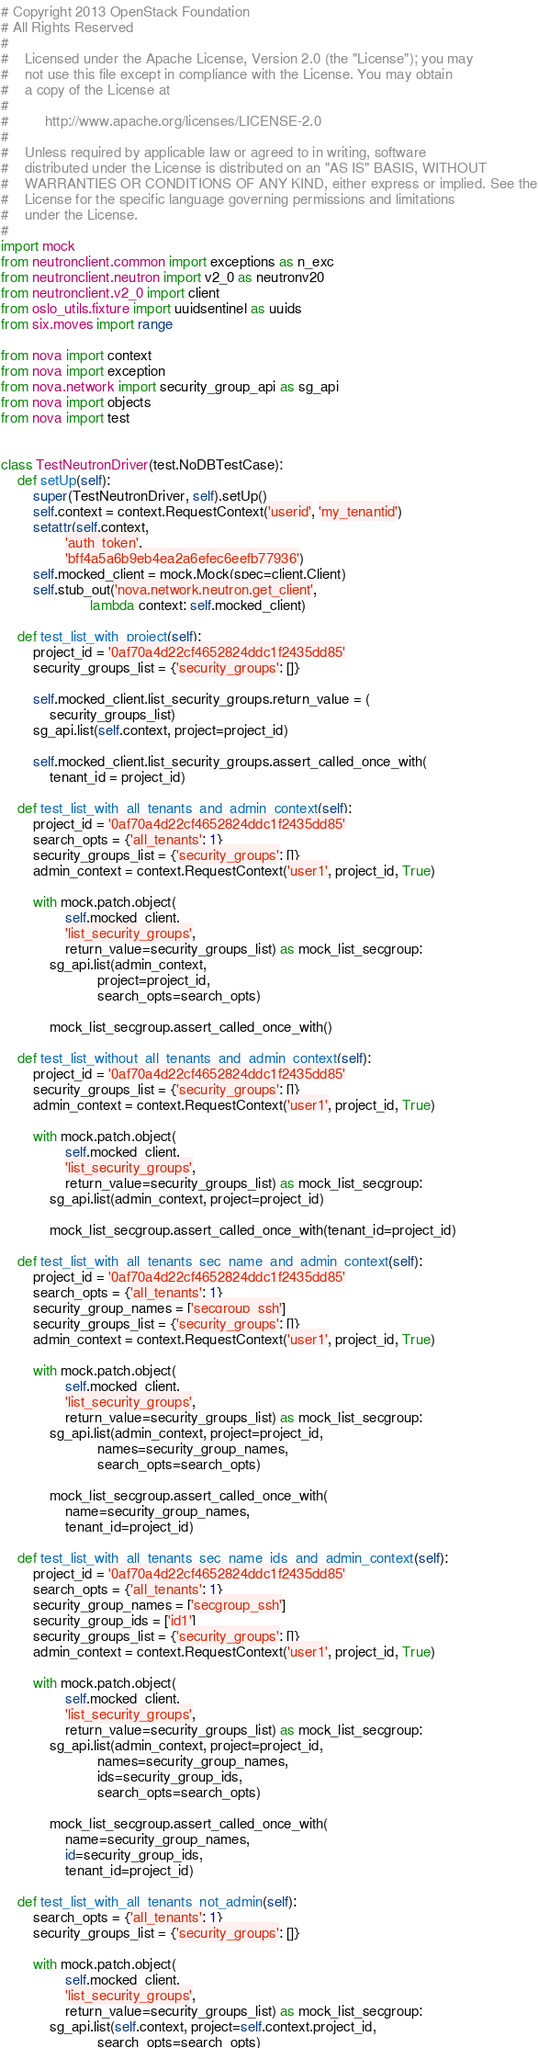Convert code to text. <code><loc_0><loc_0><loc_500><loc_500><_Python_># Copyright 2013 OpenStack Foundation
# All Rights Reserved
#
#    Licensed under the Apache License, Version 2.0 (the "License"); you may
#    not use this file except in compliance with the License. You may obtain
#    a copy of the License at
#
#         http://www.apache.org/licenses/LICENSE-2.0
#
#    Unless required by applicable law or agreed to in writing, software
#    distributed under the License is distributed on an "AS IS" BASIS, WITHOUT
#    WARRANTIES OR CONDITIONS OF ANY KIND, either express or implied. See the
#    License for the specific language governing permissions and limitations
#    under the License.
#
import mock
from neutronclient.common import exceptions as n_exc
from neutronclient.neutron import v2_0 as neutronv20
from neutronclient.v2_0 import client
from oslo_utils.fixture import uuidsentinel as uuids
from six.moves import range

from nova import context
from nova import exception
from nova.network import security_group_api as sg_api
from nova import objects
from nova import test


class TestNeutronDriver(test.NoDBTestCase):
    def setUp(self):
        super(TestNeutronDriver, self).setUp()
        self.context = context.RequestContext('userid', 'my_tenantid')
        setattr(self.context,
                'auth_token',
                'bff4a5a6b9eb4ea2a6efec6eefb77936')
        self.mocked_client = mock.Mock(spec=client.Client)
        self.stub_out('nova.network.neutron.get_client',
                      lambda context: self.mocked_client)

    def test_list_with_project(self):
        project_id = '0af70a4d22cf4652824ddc1f2435dd85'
        security_groups_list = {'security_groups': []}

        self.mocked_client.list_security_groups.return_value = (
            security_groups_list)
        sg_api.list(self.context, project=project_id)

        self.mocked_client.list_security_groups.assert_called_once_with(
            tenant_id = project_id)

    def test_list_with_all_tenants_and_admin_context(self):
        project_id = '0af70a4d22cf4652824ddc1f2435dd85'
        search_opts = {'all_tenants': 1}
        security_groups_list = {'security_groups': []}
        admin_context = context.RequestContext('user1', project_id, True)

        with mock.patch.object(
                self.mocked_client,
                'list_security_groups',
                return_value=security_groups_list) as mock_list_secgroup:
            sg_api.list(admin_context,
                        project=project_id,
                        search_opts=search_opts)

            mock_list_secgroup.assert_called_once_with()

    def test_list_without_all_tenants_and_admin_context(self):
        project_id = '0af70a4d22cf4652824ddc1f2435dd85'
        security_groups_list = {'security_groups': []}
        admin_context = context.RequestContext('user1', project_id, True)

        with mock.patch.object(
                self.mocked_client,
                'list_security_groups',
                return_value=security_groups_list) as mock_list_secgroup:
            sg_api.list(admin_context, project=project_id)

            mock_list_secgroup.assert_called_once_with(tenant_id=project_id)

    def test_list_with_all_tenants_sec_name_and_admin_context(self):
        project_id = '0af70a4d22cf4652824ddc1f2435dd85'
        search_opts = {'all_tenants': 1}
        security_group_names = ['secgroup_ssh']
        security_groups_list = {'security_groups': []}
        admin_context = context.RequestContext('user1', project_id, True)

        with mock.patch.object(
                self.mocked_client,
                'list_security_groups',
                return_value=security_groups_list) as mock_list_secgroup:
            sg_api.list(admin_context, project=project_id,
                        names=security_group_names,
                        search_opts=search_opts)

            mock_list_secgroup.assert_called_once_with(
                name=security_group_names,
                tenant_id=project_id)

    def test_list_with_all_tenants_sec_name_ids_and_admin_context(self):
        project_id = '0af70a4d22cf4652824ddc1f2435dd85'
        search_opts = {'all_tenants': 1}
        security_group_names = ['secgroup_ssh']
        security_group_ids = ['id1']
        security_groups_list = {'security_groups': []}
        admin_context = context.RequestContext('user1', project_id, True)

        with mock.patch.object(
                self.mocked_client,
                'list_security_groups',
                return_value=security_groups_list) as mock_list_secgroup:
            sg_api.list(admin_context, project=project_id,
                        names=security_group_names,
                        ids=security_group_ids,
                        search_opts=search_opts)

            mock_list_secgroup.assert_called_once_with(
                name=security_group_names,
                id=security_group_ids,
                tenant_id=project_id)

    def test_list_with_all_tenants_not_admin(self):
        search_opts = {'all_tenants': 1}
        security_groups_list = {'security_groups': []}

        with mock.patch.object(
                self.mocked_client,
                'list_security_groups',
                return_value=security_groups_list) as mock_list_secgroup:
            sg_api.list(self.context, project=self.context.project_id,
                        search_opts=search_opts)
</code> 